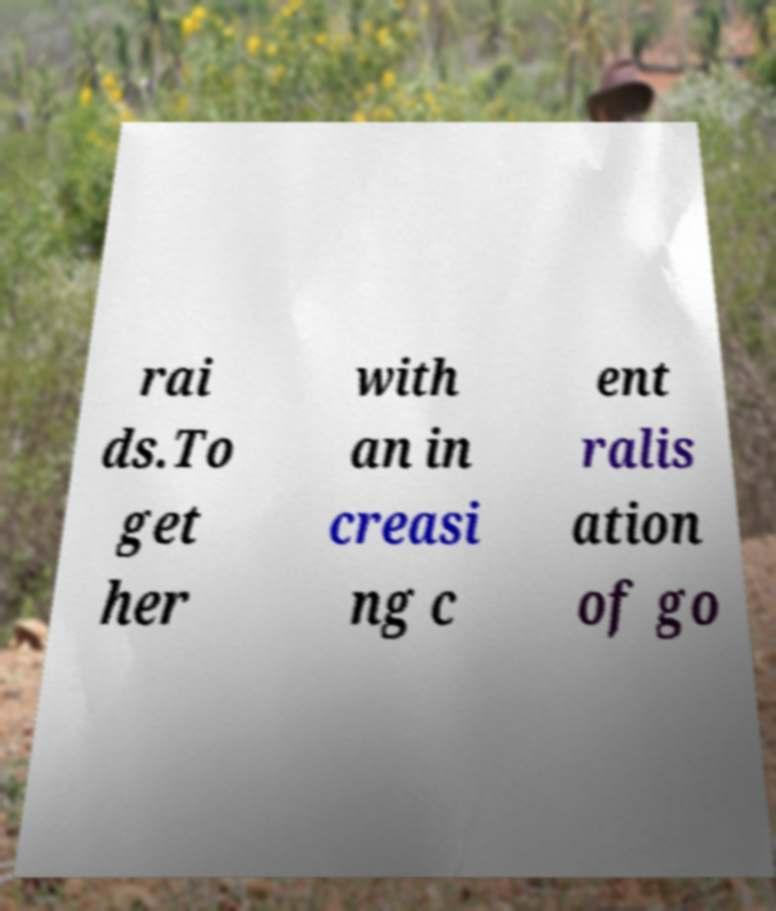Please identify and transcribe the text found in this image. rai ds.To get her with an in creasi ng c ent ralis ation of go 